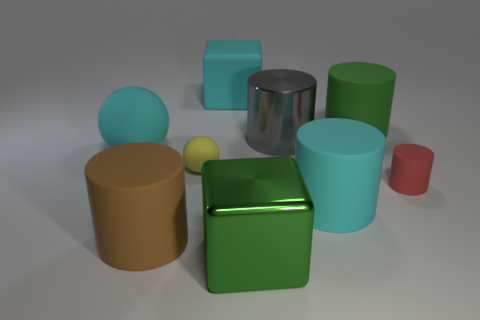Subtract all gray cylinders. How many cylinders are left? 4 Add 1 purple metallic cylinders. How many objects exist? 10 Subtract all brown cylinders. How many cylinders are left? 4 Subtract 1 cubes. How many cubes are left? 1 Subtract all cylinders. How many objects are left? 4 Subtract all big yellow balls. Subtract all large gray shiny cylinders. How many objects are left? 8 Add 7 tiny yellow rubber objects. How many tiny yellow rubber objects are left? 8 Add 3 large shiny cylinders. How many large shiny cylinders exist? 4 Subtract 0 yellow cylinders. How many objects are left? 9 Subtract all brown cylinders. Subtract all yellow cubes. How many cylinders are left? 4 